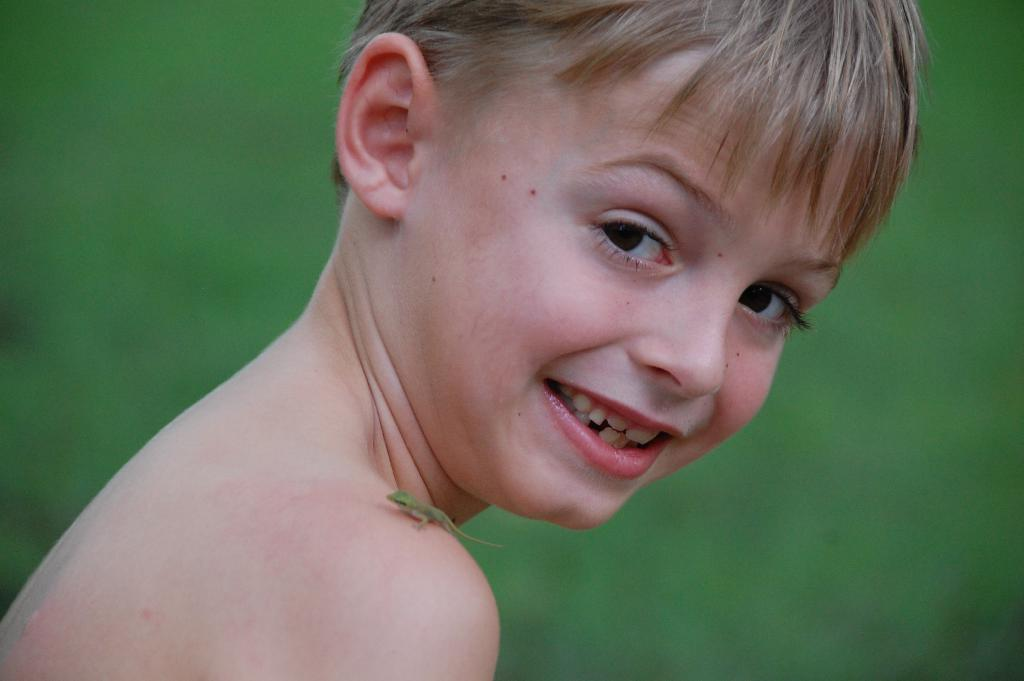Who is the main subject in the picture? There is a boy in the picture. Is there anything unusual on the boy's shoulder? Yes, there appears to be a lizard on the boy's right shoulder. Can you describe the background of the image? The background of the image is blurry. What type of vacation is the boy planning to go on with his friends in the image? There is no information about a vacation or friends in the image; it only shows a boy with a lizard on his shoulder and a blurry background. 